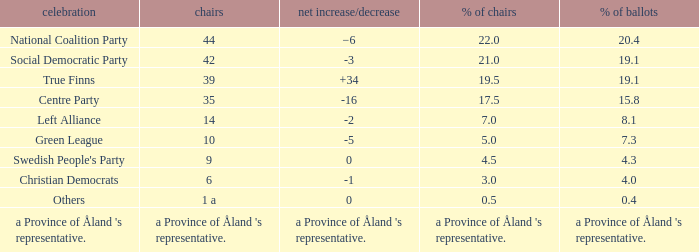Regarding the seats that casted 8.1% of the vote how many seats were held? 14.0. 